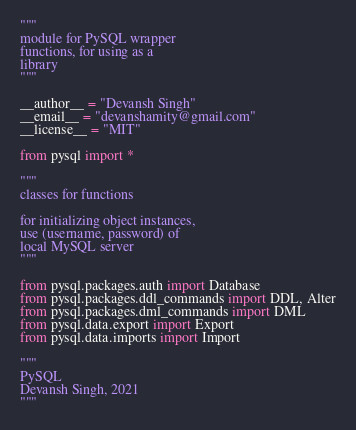Convert code to text. <code><loc_0><loc_0><loc_500><loc_500><_Python_>"""
module for PySQL wrapper
functions, for using as a
library
"""

__author__ = "Devansh Singh"
__email__ = "devanshamity@gmail.com"
__license__ = "MIT"

from pysql import *

"""
classes for functions

for initializing object instances,
use (username, password) of
local MySQL server
"""

from pysql.packages.auth import Database
from pysql.packages.ddl_commands import DDL, Alter
from pysql.packages.dml_commands import DML
from pysql.data.export import Export
from pysql.data.imports import Import

"""
PySQL
Devansh Singh, 2021
"""
</code> 